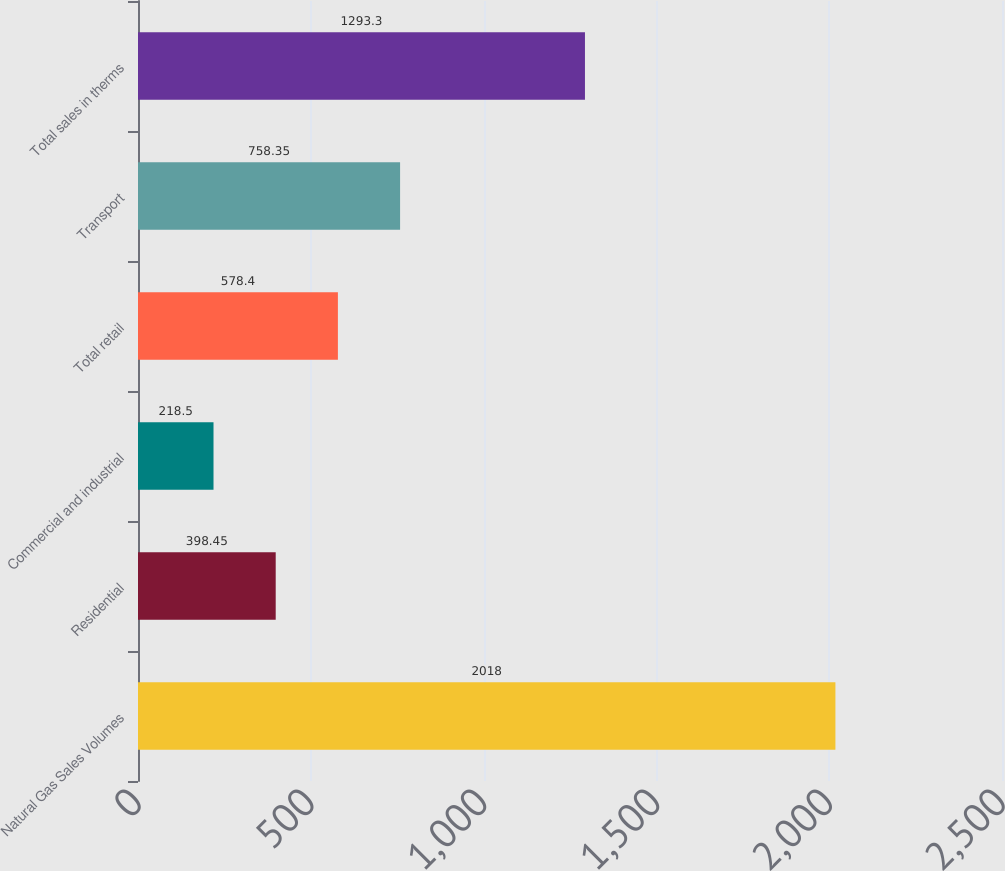<chart> <loc_0><loc_0><loc_500><loc_500><bar_chart><fcel>Natural Gas Sales Volumes<fcel>Residential<fcel>Commercial and industrial<fcel>Total retail<fcel>Transport<fcel>Total sales in therms<nl><fcel>2018<fcel>398.45<fcel>218.5<fcel>578.4<fcel>758.35<fcel>1293.3<nl></chart> 